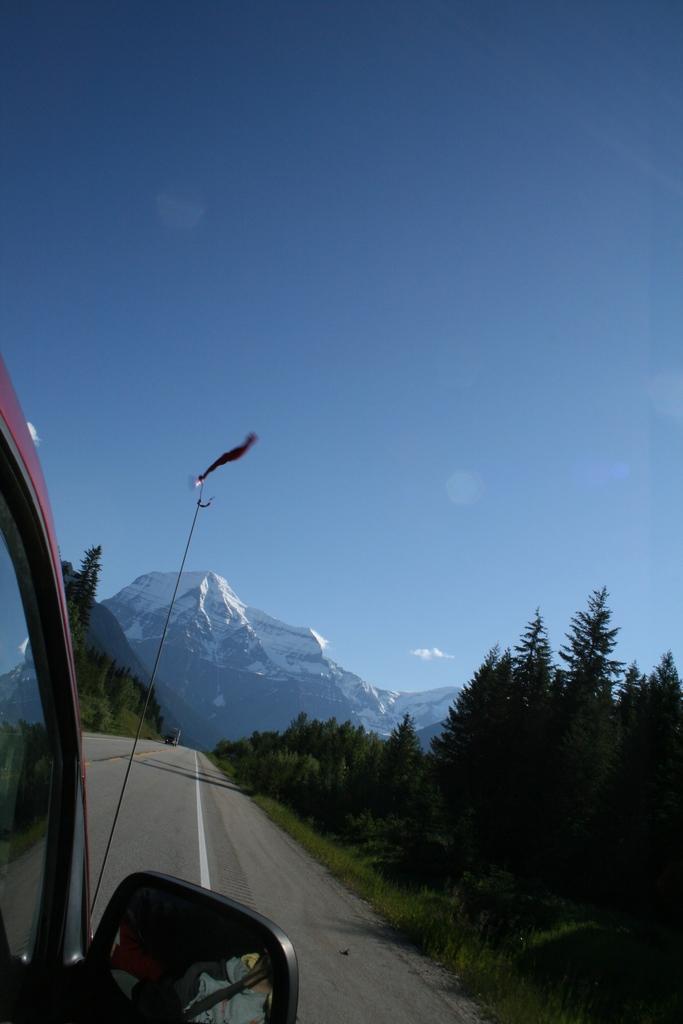Describe this image in one or two sentences. In the picture I can see a vehicle on the road. In the background I can see trees, mountains, the sky and some other objects. 